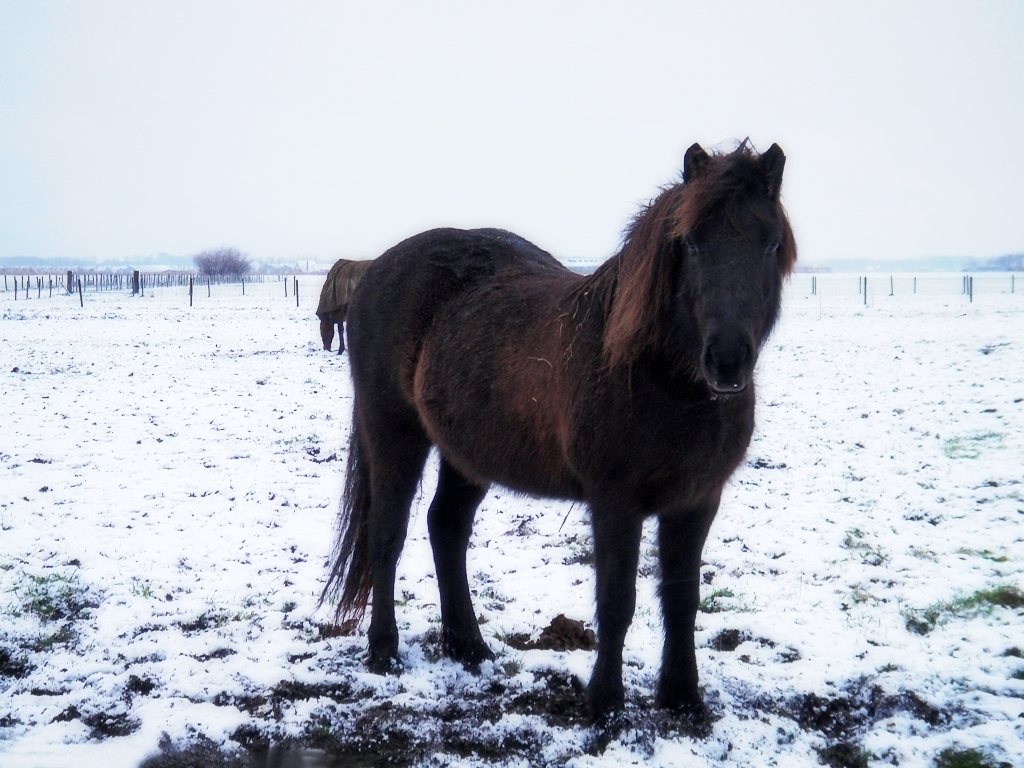Are the details in the snow area clear? The snow-covered ground in the image possesses a texture that suggests a light dusting, with specks of underlying grass and soil peeking through. However, due to the overcast sky and the uniform color of the snow, fine details may not be as clear as one might see on a bright sunny day, or with higher contrast between light and shadow. 